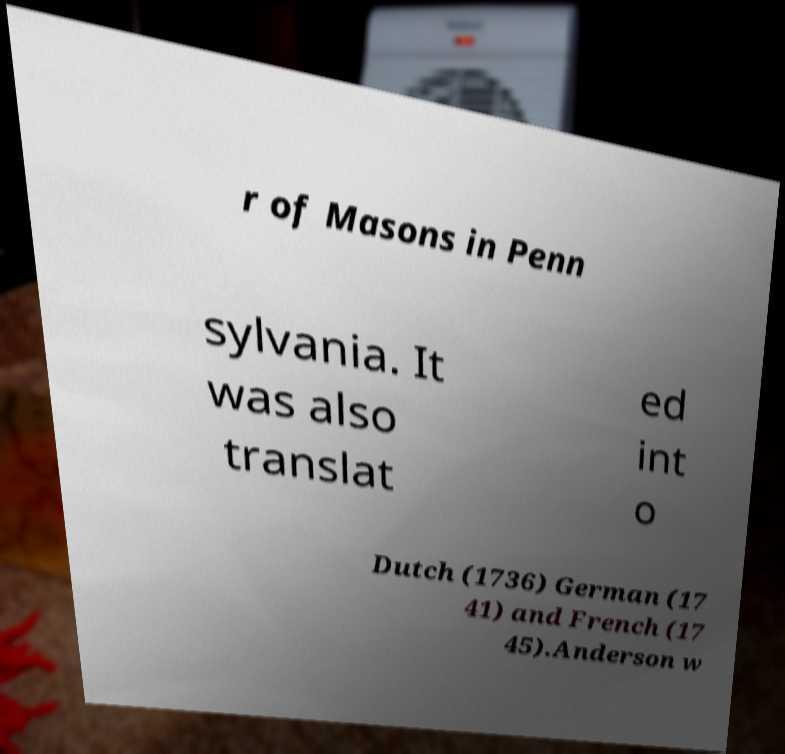Could you assist in decoding the text presented in this image and type it out clearly? r of Masons in Penn sylvania. It was also translat ed int o Dutch (1736) German (17 41) and French (17 45).Anderson w 